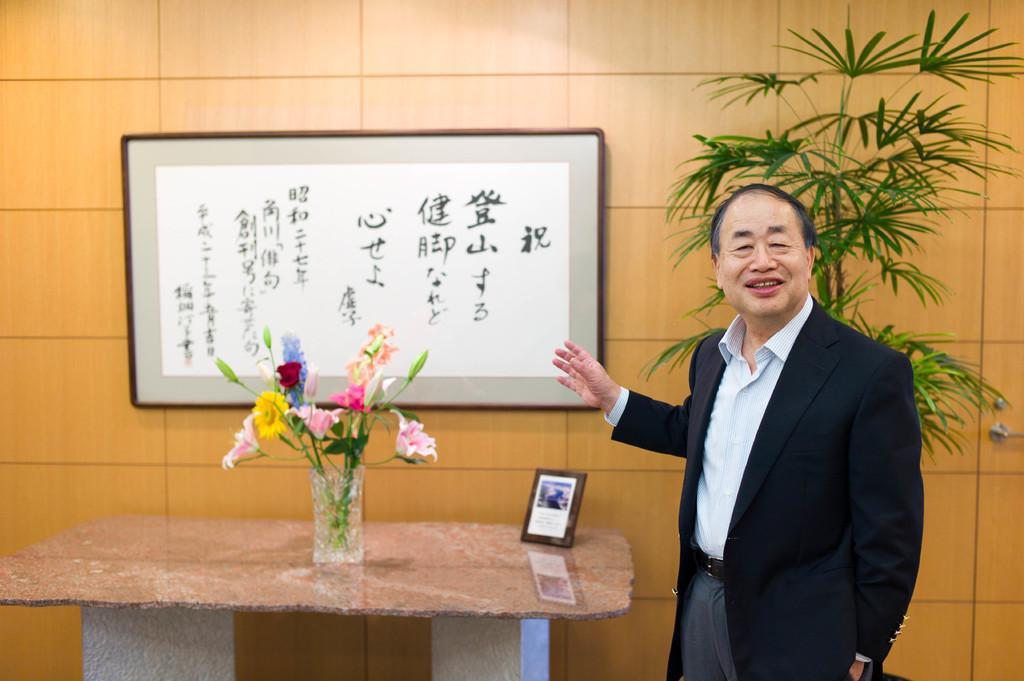How would you summarize this image in a sentence or two? In the image there is a guy stood right side corner you are showing a photo frame on which it was written on Chinese script and in front there is a flower vase on a table and a photo frame beside it backside of him there is a plant. 